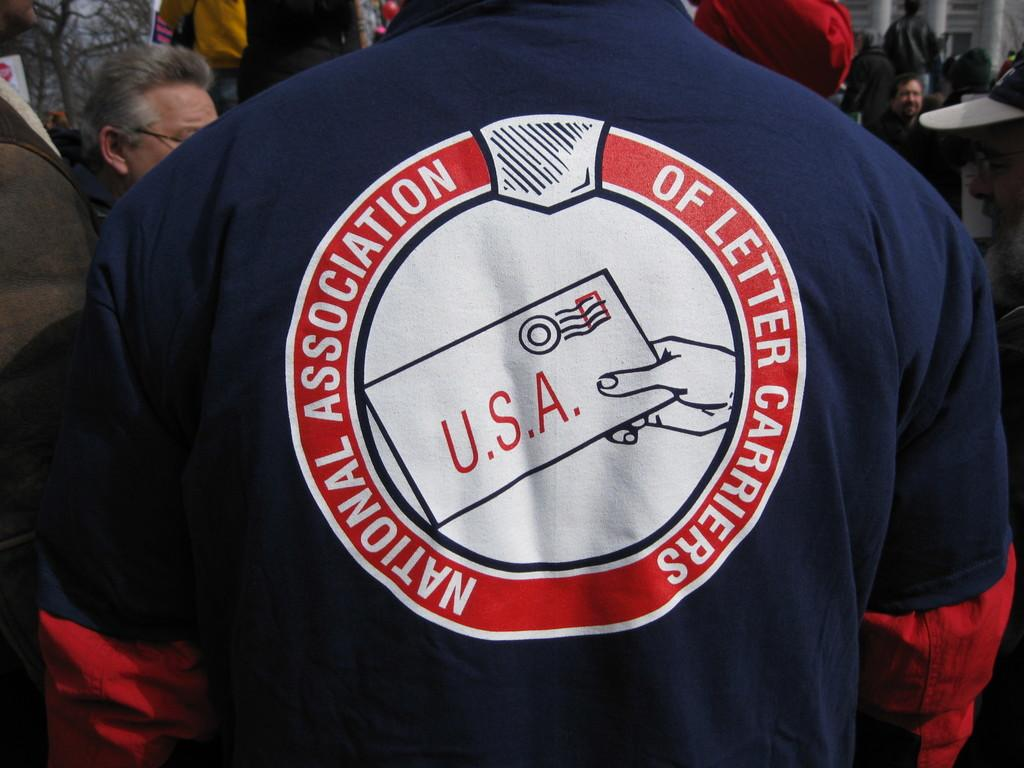What is the man in the image doing? The man is standing in the image. What is the man wearing in the image? The man is wearing a t-shirt in the image. What can be seen on the t-shirt? The t-shirt has text on it. Can you describe the background of the image? There is a group of people on the backside of the image, pillars are visible, and there is a tree in the image. How many mice are climbing up the tree in the image? There are no mice present in the image, and therefore no mice climbing up the tree. What type of twist can be seen in the image? There is no twist present in the image. 